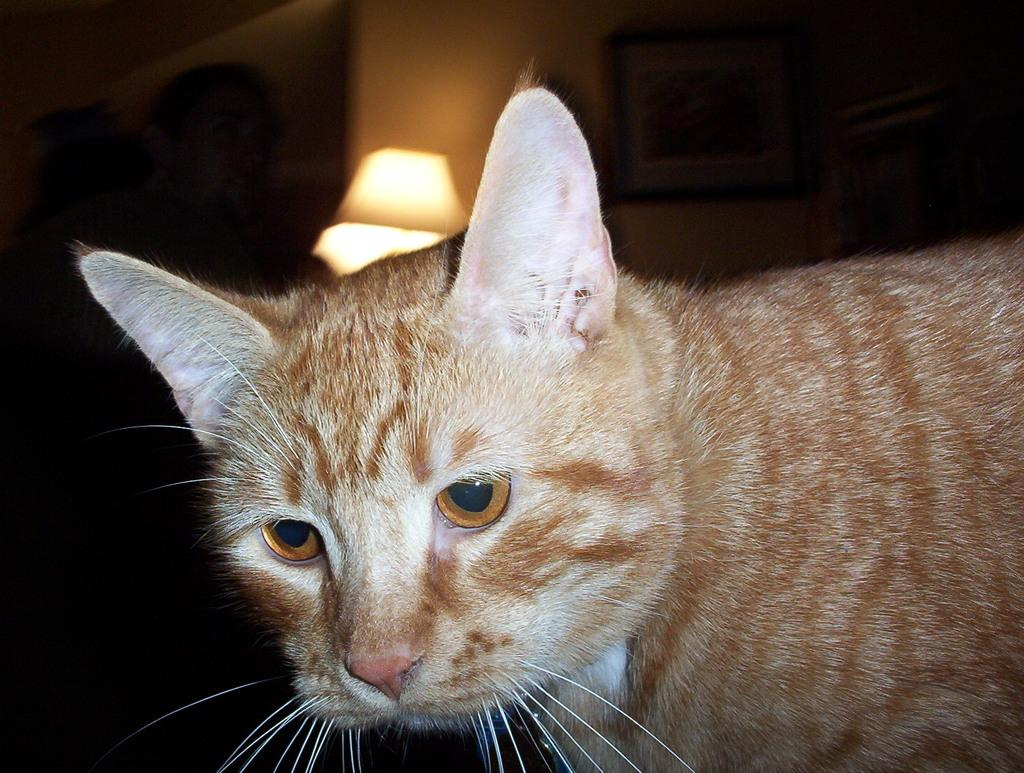What type of animal can be seen in the image? There is a cat present in the image. Can you describe the color of the cat? The cat is in brown and cream color. What objects can be seen in the background of the image? There is a lamp and a photo frame fixed to the wall in the background of the image. Is the queen sitting next to the cat in the image? There is no queen present in the image; it only features a cat. Can you see a toothbrush in the image? There is no toothbrush visible in the image. 